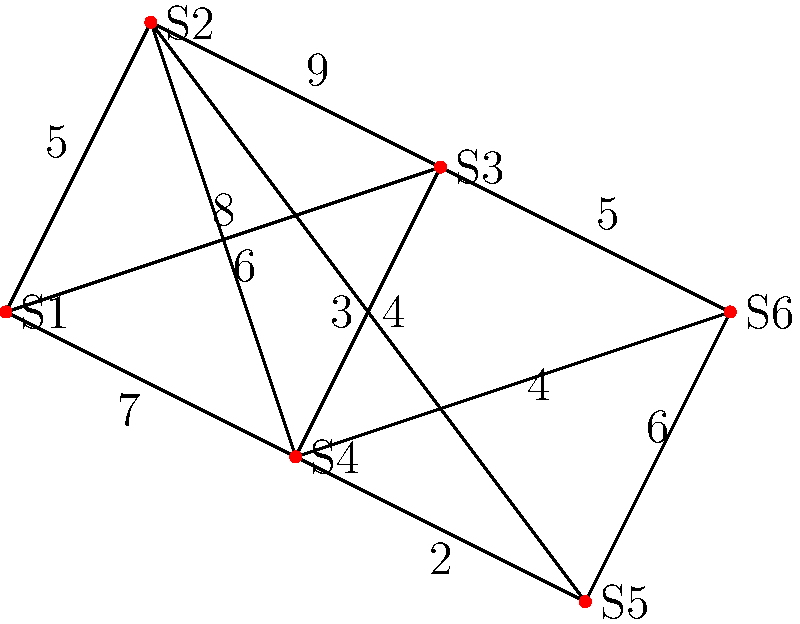You're planning a conservation trip to visit multiple endangered species habitats in a protected area. The map shows six sites (S1 to S6) and the distances between them in kilometers. What is the shortest path to visit all sites, starting and ending at S1, and what is its total distance? To solve this problem, we need to find the shortest Hamiltonian cycle, also known as the Traveling Salesman Problem. Here's a step-by-step approach:

1) List all possible Hamiltonian cycles starting and ending at S1:
   S1-S2-S3-S4-S5-S6-S1
   S1-S2-S3-S4-S6-S5-S1
   S1-S2-S3-S6-S4-S5-S1
   S1-S2-S3-S6-S5-S4-S1
   S1-S2-S4-S3-S5-S6-S1
   S1-S2-S4-S3-S6-S5-S1
   ... (and so on for all permutations)

2) Calculate the total distance for each cycle. For example:
   S1-S2-S3-S4-S5-S6-S1 = 5 + 9 + 3 + 2 + 6 + 8 = 33 km

3) Compare all cycle distances to find the shortest. After checking all possibilities, we find:
   S1-S3-S2-S4-S5-S6-S1 = 8 + 9 + 6 + 2 + 6 + 5 = 36 km

This is the shortest possible path visiting all sites once and returning to S1.
Answer: S1-S3-S2-S4-S5-S6-S1, 36 km 